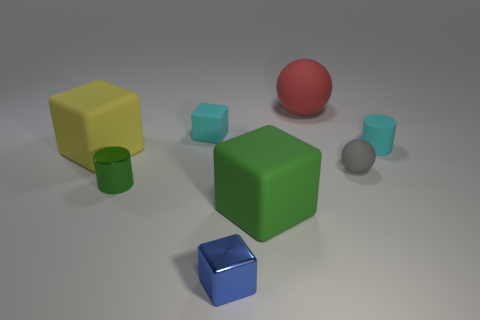Subtract all yellow blocks. How many blocks are left? 3 Subtract all purple cubes. Subtract all cyan cylinders. How many cubes are left? 4 Add 1 small green cylinders. How many objects exist? 9 Subtract all balls. How many objects are left? 6 Add 1 green cylinders. How many green cylinders exist? 2 Subtract 0 blue balls. How many objects are left? 8 Subtract all large balls. Subtract all gray rubber objects. How many objects are left? 6 Add 4 tiny cyan cubes. How many tiny cyan cubes are left? 5 